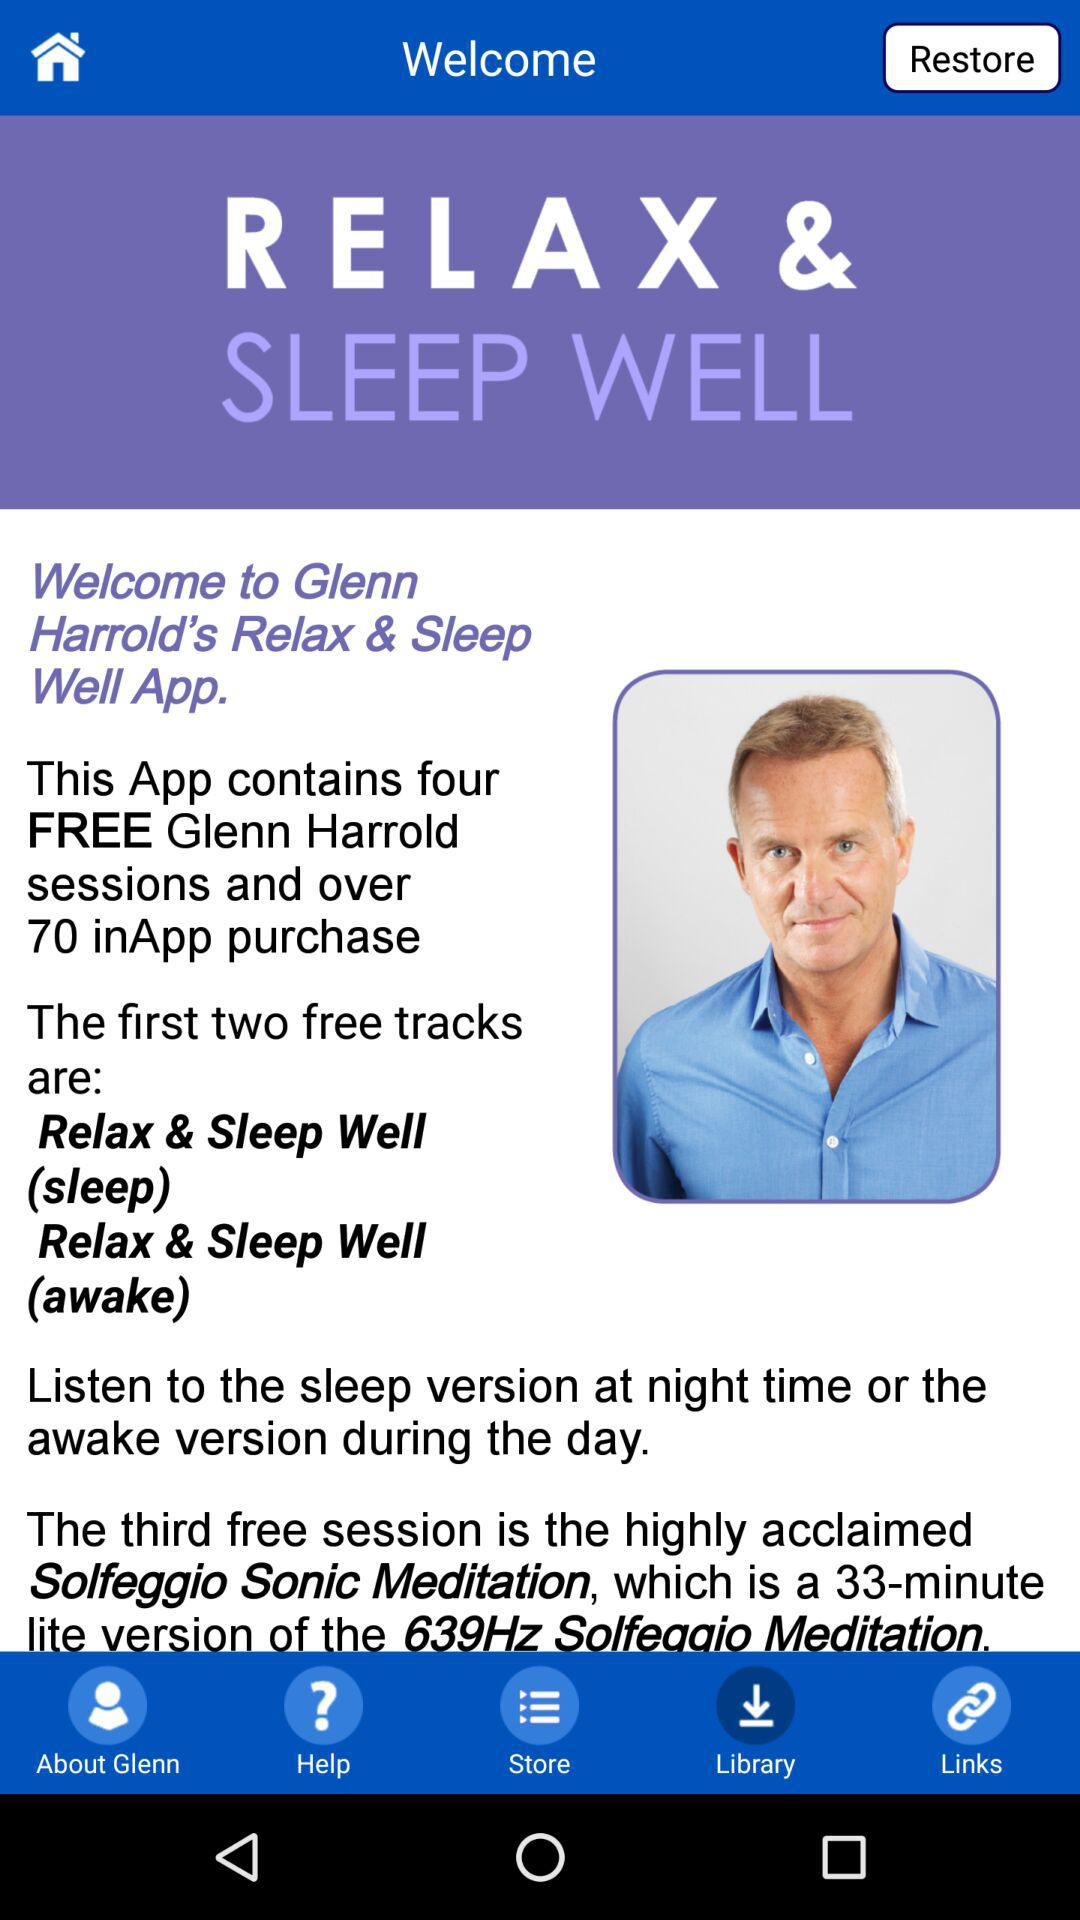What is the app name? The app name is "RELAX & SLEEP WELL". 